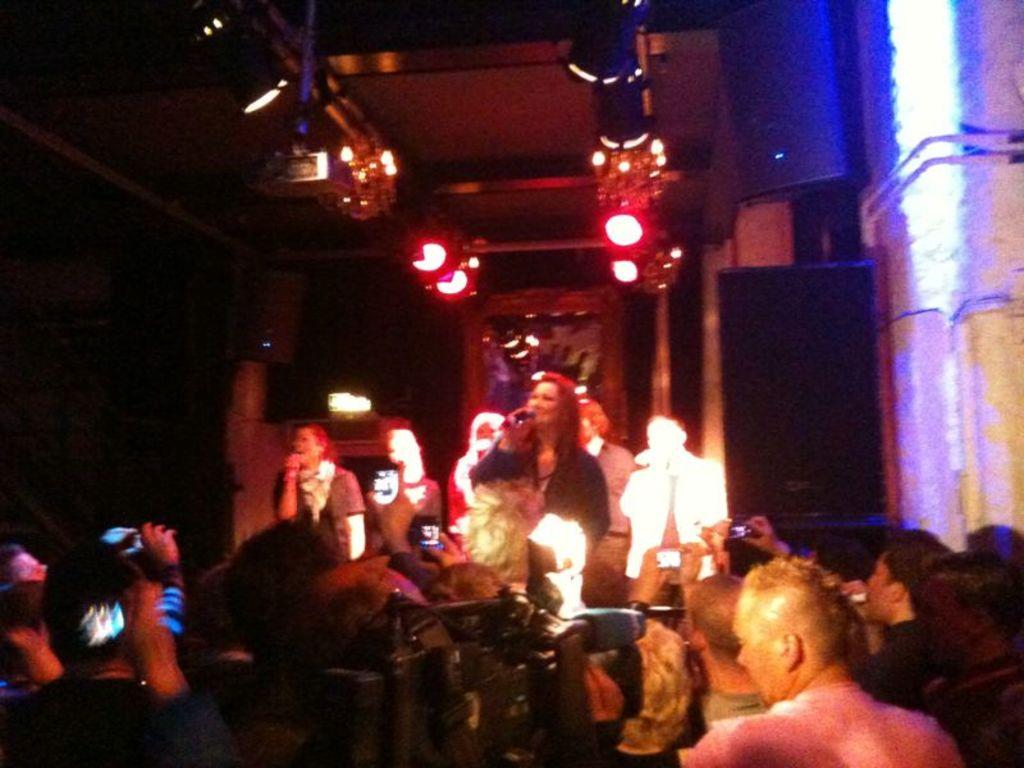Who or what can be seen in the image? There are people in the image. What can be observed in addition to the people? There are lights and unspecified objects in the image. How would you describe the overall appearance of the image? The background of the image is dark. What type of caption is written on the locket in the image? There is no locket present in the image, so it is not possible to answer that question. 